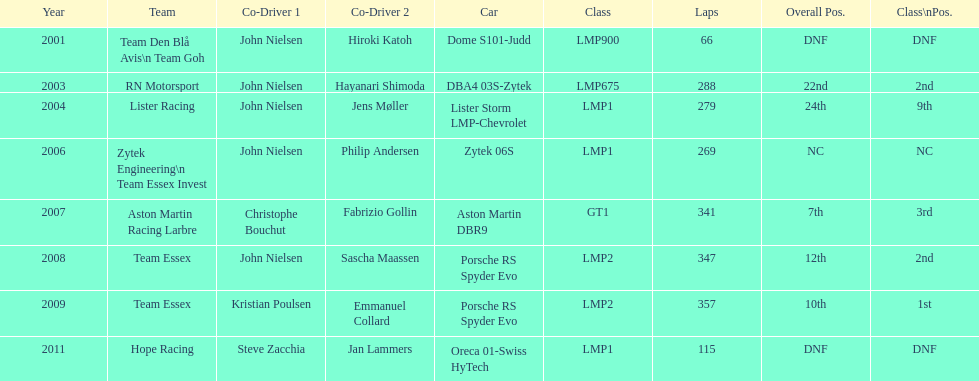How many times was the final position above 20? 2. 